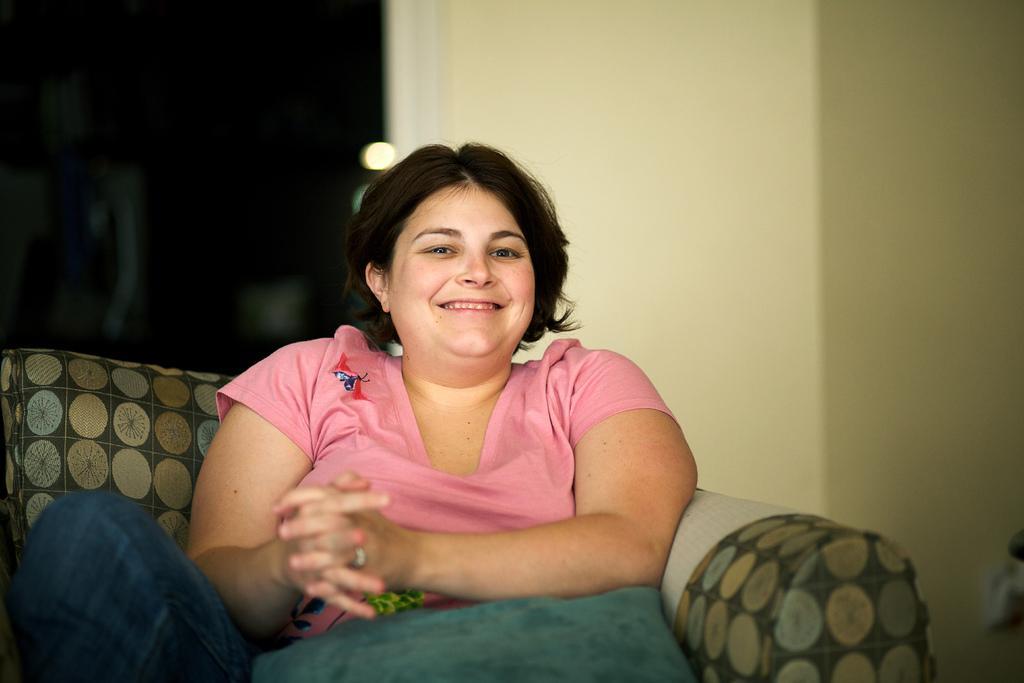Please provide a concise description of this image. In the image there is a woman in pink t-shirt sitting on a sofa and behind her there is wall. 